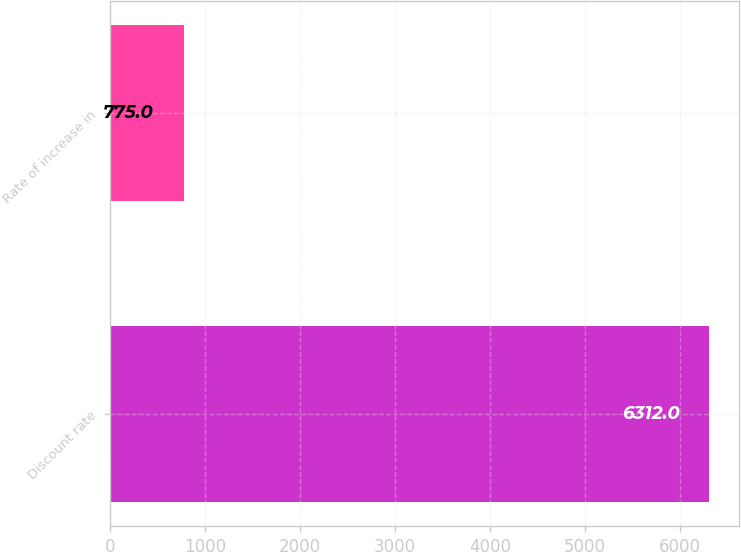Convert chart. <chart><loc_0><loc_0><loc_500><loc_500><bar_chart><fcel>Discount rate<fcel>Rate of increase in<nl><fcel>6312<fcel>775<nl></chart> 